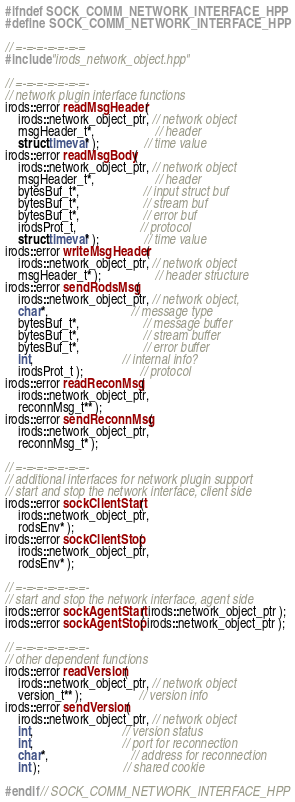<code> <loc_0><loc_0><loc_500><loc_500><_C++_>

#ifndef SOCK_COMM_NETWORK_INTERFACE_HPP
#define SOCK_COMM_NETWORK_INTERFACE_HPP

// =-=-=-=-=-=-=
#include "irods_network_object.hpp"

// =-=-=-=-=-=-=-
// network plugin interface functions
irods::error readMsgHeader(
    irods::network_object_ptr, // network object
    msgHeader_t*,                   // header
    struct timeval* );              // time value
irods::error readMsgBody(
    irods::network_object_ptr, // network object
    msgHeader_t*,                   // header
    bytesBuf_t*,                    // input struct buf
    bytesBuf_t*,                    // stream buf
    bytesBuf_t*,                    // error buf
    irodsProt_t,                    // protocol
    struct timeval* );              // time value
irods::error writeMsgHeader(
    irods::network_object_ptr, // network object
    msgHeader_t* );                 // header structure
irods::error sendRodsMsg(
    irods::network_object_ptr, // network object,
    char*,                          // message type
    bytesBuf_t*,                    // message buffer
    bytesBuf_t*,                    // stream buffer
    bytesBuf_t*,                    // error buffer
    int,                            // internal info?
    irodsProt_t );                  // protocol
irods::error readReconMsg(
    irods::network_object_ptr,
    reconnMsg_t** );
irods::error sendReconnMsg(
    irods::network_object_ptr,
    reconnMsg_t* );

// =-=-=-=-=-=-=-
// additional interfaces for network plugin support
// start and stop the network interface, client side
irods::error sockClientStart(
    irods::network_object_ptr,
    rodsEnv* );
irods::error sockClientStop(
    irods::network_object_ptr,
    rodsEnv* );

// =-=-=-=-=-=-=-
// start and stop the network interface, agent side
irods::error sockAgentStart( irods::network_object_ptr );
irods::error sockAgentStop( irods::network_object_ptr );

// =-=-=-=-=-=-=-
// other dependent functions
irods::error readVersion(
    irods::network_object_ptr, // network object
    version_t** );                  // version info
irods::error sendVersion(
    irods::network_object_ptr, // network object
    int,                            // version status
    int,                            // port for reconnection
    char*,                          // address for reconnection
    int );                          // shared cookie

#endif // SOCK_COMM_NETWORK_INTERFACE_HPP



</code> 